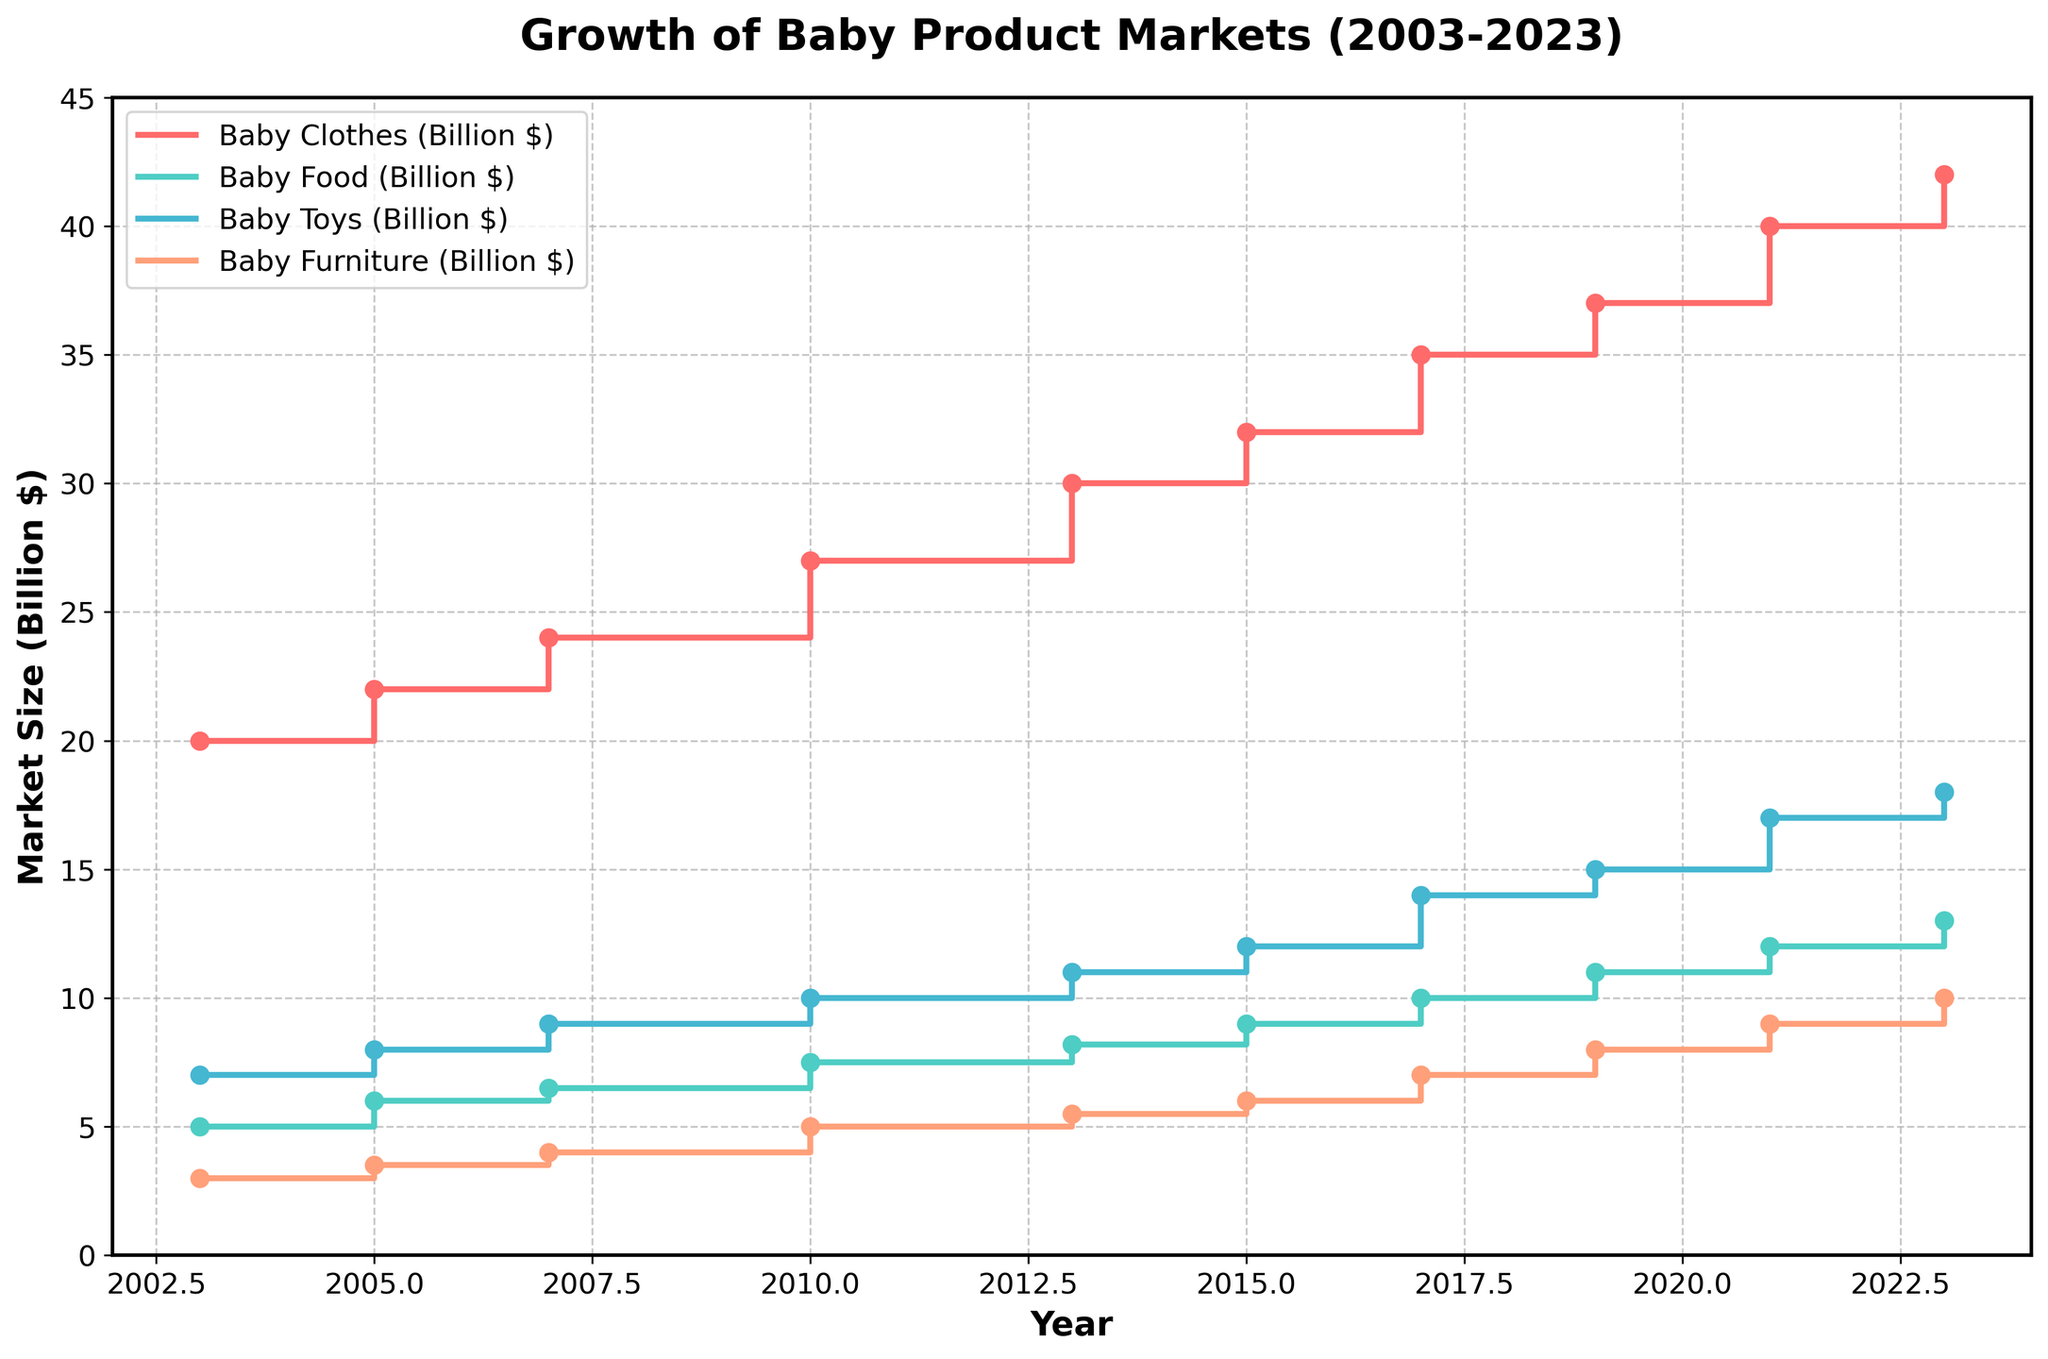What's the title of the figure? The title is usually at the top of the figure. In this case, the title is clearly stated as "Growth of Baby Product Markets (2003-2023)."
Answer: Growth of Baby Product Markets (2003-2023) How many categories of baby products are shown in the figure? Count the number of distinct lines or color-coded sections in the legend. Here, there are four categories listed: Baby Clothes, Baby Food, Baby Toys, and Baby Furniture.
Answer: Four Which year shows the largest market size for Baby Clothes? Locate the line representing Baby Clothes and follow it to its highest point on the x-axis. The highest point for Baby Clothes is in the year 2023.
Answer: 2023 What is the market size for Baby Food in 2013? Identify the Baby Food line and find the corresponding value on the y-axis for the year 2013. The market size for Baby Food in 2013 is 8.2 billion dollars.
Answer: 8.2 billion dollars How much did the Baby Toys market grow between 2010 and 2021? Locate the values for Baby Toys in the years 2010 and 2021. The market sizes are 10 billion dollars in 2010 and 17 billion dollars in 2021. Subtract the 2010 value from the 2021 value: 17 - 10 = 7 billion dollars.
Answer: 7 billion dollars Which category had the smallest market size in 2003, and what was it? Compare the market sizes of all categories in 2003. The smallest value is for Baby Furniture, which had a market size of 3 billion dollars.
Answer: Baby Furniture, 3 billion dollars Has the market size for Baby Furniture ever decreased over the years? Follow the Baby Furniture line on the plot. The values consistently increase or remain the same; there is no decrease observed.
Answer: No How does the growth trend for Baby Clothes from 2003 to 2023 compare to Baby Toys? Examine the slope of the lines for both categories over the years. Both lines show an upward trend, but Baby Toys experience more rapid growth, especially noticeable after 2015.
Answer: Baby Toys grew more rapidly than Baby Clothes Which two categories had the most similar market sizes in 2005, and what were those sizes? Compare the values for each category in 2005. Baby Food and Baby Toys both had market sizes close to each other with 6 billion dollars and 8 billion dollars, respectively.
Answer: Baby Food (6 billion dollars) and Baby Toys (8 billion dollars) 